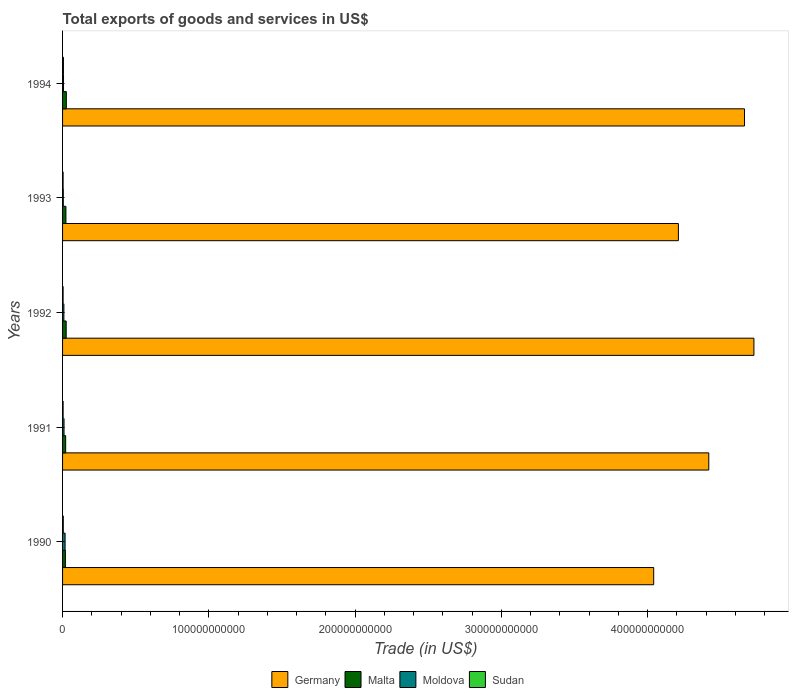How many groups of bars are there?
Give a very brief answer. 5. Are the number of bars on each tick of the Y-axis equal?
Your answer should be compact. Yes. How many bars are there on the 5th tick from the top?
Give a very brief answer. 4. How many bars are there on the 3rd tick from the bottom?
Offer a very short reply. 4. What is the total exports of goods and services in Malta in 1991?
Provide a succinct answer. 2.13e+09. Across all years, what is the maximum total exports of goods and services in Moldova?
Your response must be concise. 1.73e+09. Across all years, what is the minimum total exports of goods and services in Sudan?
Offer a very short reply. 3.69e+08. In which year was the total exports of goods and services in Sudan maximum?
Make the answer very short. 1994. In which year was the total exports of goods and services in Moldova minimum?
Ensure brevity in your answer.  1993. What is the total total exports of goods and services in Malta in the graph?
Your answer should be very brief. 1.14e+1. What is the difference between the total exports of goods and services in Sudan in 1992 and that in 1994?
Make the answer very short. -2.31e+08. What is the difference between the total exports of goods and services in Sudan in 1994 and the total exports of goods and services in Malta in 1993?
Your answer should be very brief. -1.70e+09. What is the average total exports of goods and services in Sudan per year?
Keep it short and to the point. 4.45e+08. In the year 1994, what is the difference between the total exports of goods and services in Sudan and total exports of goods and services in Malta?
Make the answer very short. -1.98e+09. What is the ratio of the total exports of goods and services in Sudan in 1992 to that in 1993?
Your answer should be compact. 0.98. Is the difference between the total exports of goods and services in Sudan in 1991 and 1994 greater than the difference between the total exports of goods and services in Malta in 1991 and 1994?
Your response must be concise. Yes. What is the difference between the highest and the second highest total exports of goods and services in Moldova?
Offer a terse response. 7.33e+08. What is the difference between the highest and the lowest total exports of goods and services in Moldova?
Your response must be concise. 1.23e+09. Is the sum of the total exports of goods and services in Moldova in 1991 and 1994 greater than the maximum total exports of goods and services in Malta across all years?
Your response must be concise. No. What does the 1st bar from the top in 1994 represents?
Offer a very short reply. Sudan. What does the 4th bar from the bottom in 1993 represents?
Keep it short and to the point. Sudan. How many bars are there?
Give a very brief answer. 20. What is the difference between two consecutive major ticks on the X-axis?
Provide a short and direct response. 1.00e+11. Are the values on the major ticks of X-axis written in scientific E-notation?
Offer a terse response. No. Does the graph contain grids?
Make the answer very short. No. How many legend labels are there?
Your answer should be very brief. 4. What is the title of the graph?
Keep it short and to the point. Total exports of goods and services in US$. Does "Hungary" appear as one of the legend labels in the graph?
Your answer should be very brief. No. What is the label or title of the X-axis?
Your answer should be compact. Trade (in US$). What is the Trade (in US$) in Germany in 1990?
Give a very brief answer. 4.04e+11. What is the Trade (in US$) in Malta in 1990?
Make the answer very short. 1.93e+09. What is the Trade (in US$) in Moldova in 1990?
Your answer should be very brief. 1.73e+09. What is the Trade (in US$) in Sudan in 1990?
Give a very brief answer. 4.99e+08. What is the Trade (in US$) in Germany in 1991?
Your answer should be very brief. 4.42e+11. What is the Trade (in US$) of Malta in 1991?
Keep it short and to the point. 2.13e+09. What is the Trade (in US$) in Moldova in 1991?
Give a very brief answer. 1.00e+09. What is the Trade (in US$) of Sudan in 1991?
Your response must be concise. 3.80e+08. What is the Trade (in US$) in Germany in 1992?
Keep it short and to the point. 4.73e+11. What is the Trade (in US$) in Malta in 1992?
Provide a succinct answer. 2.47e+09. What is the Trade (in US$) of Moldova in 1992?
Make the answer very short. 9.03e+08. What is the Trade (in US$) in Sudan in 1992?
Your answer should be compact. 3.69e+08. What is the Trade (in US$) in Germany in 1993?
Provide a succinct answer. 4.21e+11. What is the Trade (in US$) in Malta in 1993?
Your answer should be compact. 2.30e+09. What is the Trade (in US$) in Moldova in 1993?
Give a very brief answer. 5.01e+08. What is the Trade (in US$) in Sudan in 1993?
Provide a succinct answer. 3.76e+08. What is the Trade (in US$) of Germany in 1994?
Provide a short and direct response. 4.66e+11. What is the Trade (in US$) in Malta in 1994?
Your answer should be compact. 2.58e+09. What is the Trade (in US$) of Moldova in 1994?
Make the answer very short. 6.51e+08. What is the Trade (in US$) in Sudan in 1994?
Your response must be concise. 6.00e+08. Across all years, what is the maximum Trade (in US$) in Germany?
Ensure brevity in your answer.  4.73e+11. Across all years, what is the maximum Trade (in US$) in Malta?
Your answer should be very brief. 2.58e+09. Across all years, what is the maximum Trade (in US$) of Moldova?
Make the answer very short. 1.73e+09. Across all years, what is the maximum Trade (in US$) in Sudan?
Offer a terse response. 6.00e+08. Across all years, what is the minimum Trade (in US$) in Germany?
Keep it short and to the point. 4.04e+11. Across all years, what is the minimum Trade (in US$) in Malta?
Make the answer very short. 1.93e+09. Across all years, what is the minimum Trade (in US$) in Moldova?
Your answer should be compact. 5.01e+08. Across all years, what is the minimum Trade (in US$) in Sudan?
Keep it short and to the point. 3.69e+08. What is the total Trade (in US$) in Germany in the graph?
Keep it short and to the point. 2.21e+12. What is the total Trade (in US$) of Malta in the graph?
Keep it short and to the point. 1.14e+1. What is the total Trade (in US$) of Moldova in the graph?
Your response must be concise. 4.79e+09. What is the total Trade (in US$) of Sudan in the graph?
Keep it short and to the point. 2.22e+09. What is the difference between the Trade (in US$) of Germany in 1990 and that in 1991?
Your response must be concise. -3.77e+1. What is the difference between the Trade (in US$) in Malta in 1990 and that in 1991?
Provide a short and direct response. -1.96e+08. What is the difference between the Trade (in US$) in Moldova in 1990 and that in 1991?
Offer a terse response. 7.33e+08. What is the difference between the Trade (in US$) in Sudan in 1990 and that in 1991?
Your answer should be compact. 1.20e+08. What is the difference between the Trade (in US$) in Germany in 1990 and that in 1992?
Your response must be concise. -6.85e+1. What is the difference between the Trade (in US$) in Malta in 1990 and that in 1992?
Ensure brevity in your answer.  -5.39e+08. What is the difference between the Trade (in US$) of Moldova in 1990 and that in 1992?
Make the answer very short. 8.29e+08. What is the difference between the Trade (in US$) of Sudan in 1990 and that in 1992?
Make the answer very short. 1.30e+08. What is the difference between the Trade (in US$) of Germany in 1990 and that in 1993?
Provide a short and direct response. -1.69e+1. What is the difference between the Trade (in US$) of Malta in 1990 and that in 1993?
Offer a terse response. -3.66e+08. What is the difference between the Trade (in US$) of Moldova in 1990 and that in 1993?
Offer a terse response. 1.23e+09. What is the difference between the Trade (in US$) in Sudan in 1990 and that in 1993?
Your answer should be very brief. 1.23e+08. What is the difference between the Trade (in US$) of Germany in 1990 and that in 1994?
Your answer should be very brief. -6.21e+1. What is the difference between the Trade (in US$) of Malta in 1990 and that in 1994?
Your response must be concise. -6.46e+08. What is the difference between the Trade (in US$) in Moldova in 1990 and that in 1994?
Your response must be concise. 1.08e+09. What is the difference between the Trade (in US$) of Sudan in 1990 and that in 1994?
Provide a short and direct response. -1.01e+08. What is the difference between the Trade (in US$) in Germany in 1991 and that in 1992?
Give a very brief answer. -3.09e+1. What is the difference between the Trade (in US$) of Malta in 1991 and that in 1992?
Give a very brief answer. -3.43e+08. What is the difference between the Trade (in US$) in Moldova in 1991 and that in 1992?
Keep it short and to the point. 9.65e+07. What is the difference between the Trade (in US$) of Sudan in 1991 and that in 1992?
Give a very brief answer. 1.05e+07. What is the difference between the Trade (in US$) of Germany in 1991 and that in 1993?
Offer a very short reply. 2.08e+1. What is the difference between the Trade (in US$) in Malta in 1991 and that in 1993?
Your answer should be compact. -1.70e+08. What is the difference between the Trade (in US$) in Moldova in 1991 and that in 1993?
Your answer should be compact. 4.99e+08. What is the difference between the Trade (in US$) of Sudan in 1991 and that in 1993?
Offer a very short reply. 3.77e+06. What is the difference between the Trade (in US$) in Germany in 1991 and that in 1994?
Keep it short and to the point. -2.44e+1. What is the difference between the Trade (in US$) of Malta in 1991 and that in 1994?
Your answer should be very brief. -4.50e+08. What is the difference between the Trade (in US$) in Moldova in 1991 and that in 1994?
Offer a terse response. 3.49e+08. What is the difference between the Trade (in US$) of Sudan in 1991 and that in 1994?
Your answer should be very brief. -2.21e+08. What is the difference between the Trade (in US$) in Germany in 1992 and that in 1993?
Give a very brief answer. 5.16e+1. What is the difference between the Trade (in US$) in Malta in 1992 and that in 1993?
Your answer should be compact. 1.73e+08. What is the difference between the Trade (in US$) in Moldova in 1992 and that in 1993?
Ensure brevity in your answer.  4.02e+08. What is the difference between the Trade (in US$) of Sudan in 1992 and that in 1993?
Ensure brevity in your answer.  -6.71e+06. What is the difference between the Trade (in US$) of Germany in 1992 and that in 1994?
Your response must be concise. 6.46e+09. What is the difference between the Trade (in US$) in Malta in 1992 and that in 1994?
Your answer should be compact. -1.07e+08. What is the difference between the Trade (in US$) of Moldova in 1992 and that in 1994?
Your answer should be compact. 2.52e+08. What is the difference between the Trade (in US$) of Sudan in 1992 and that in 1994?
Offer a very short reply. -2.31e+08. What is the difference between the Trade (in US$) in Germany in 1993 and that in 1994?
Give a very brief answer. -4.52e+1. What is the difference between the Trade (in US$) of Malta in 1993 and that in 1994?
Provide a succinct answer. -2.80e+08. What is the difference between the Trade (in US$) of Moldova in 1993 and that in 1994?
Provide a short and direct response. -1.50e+08. What is the difference between the Trade (in US$) of Sudan in 1993 and that in 1994?
Offer a terse response. -2.24e+08. What is the difference between the Trade (in US$) of Germany in 1990 and the Trade (in US$) of Malta in 1991?
Your answer should be compact. 4.02e+11. What is the difference between the Trade (in US$) of Germany in 1990 and the Trade (in US$) of Moldova in 1991?
Ensure brevity in your answer.  4.03e+11. What is the difference between the Trade (in US$) of Germany in 1990 and the Trade (in US$) of Sudan in 1991?
Ensure brevity in your answer.  4.04e+11. What is the difference between the Trade (in US$) of Malta in 1990 and the Trade (in US$) of Moldova in 1991?
Your answer should be very brief. 9.32e+08. What is the difference between the Trade (in US$) in Malta in 1990 and the Trade (in US$) in Sudan in 1991?
Offer a terse response. 1.55e+09. What is the difference between the Trade (in US$) in Moldova in 1990 and the Trade (in US$) in Sudan in 1991?
Make the answer very short. 1.35e+09. What is the difference between the Trade (in US$) in Germany in 1990 and the Trade (in US$) in Malta in 1992?
Offer a very short reply. 4.02e+11. What is the difference between the Trade (in US$) of Germany in 1990 and the Trade (in US$) of Moldova in 1992?
Provide a short and direct response. 4.03e+11. What is the difference between the Trade (in US$) of Germany in 1990 and the Trade (in US$) of Sudan in 1992?
Ensure brevity in your answer.  4.04e+11. What is the difference between the Trade (in US$) of Malta in 1990 and the Trade (in US$) of Moldova in 1992?
Give a very brief answer. 1.03e+09. What is the difference between the Trade (in US$) of Malta in 1990 and the Trade (in US$) of Sudan in 1992?
Your answer should be very brief. 1.56e+09. What is the difference between the Trade (in US$) in Moldova in 1990 and the Trade (in US$) in Sudan in 1992?
Keep it short and to the point. 1.36e+09. What is the difference between the Trade (in US$) in Germany in 1990 and the Trade (in US$) in Malta in 1993?
Keep it short and to the point. 4.02e+11. What is the difference between the Trade (in US$) of Germany in 1990 and the Trade (in US$) of Moldova in 1993?
Offer a very short reply. 4.04e+11. What is the difference between the Trade (in US$) of Germany in 1990 and the Trade (in US$) of Sudan in 1993?
Give a very brief answer. 4.04e+11. What is the difference between the Trade (in US$) of Malta in 1990 and the Trade (in US$) of Moldova in 1993?
Your response must be concise. 1.43e+09. What is the difference between the Trade (in US$) in Malta in 1990 and the Trade (in US$) in Sudan in 1993?
Offer a terse response. 1.56e+09. What is the difference between the Trade (in US$) in Moldova in 1990 and the Trade (in US$) in Sudan in 1993?
Your answer should be compact. 1.36e+09. What is the difference between the Trade (in US$) in Germany in 1990 and the Trade (in US$) in Malta in 1994?
Give a very brief answer. 4.02e+11. What is the difference between the Trade (in US$) of Germany in 1990 and the Trade (in US$) of Moldova in 1994?
Make the answer very short. 4.04e+11. What is the difference between the Trade (in US$) in Germany in 1990 and the Trade (in US$) in Sudan in 1994?
Provide a succinct answer. 4.04e+11. What is the difference between the Trade (in US$) in Malta in 1990 and the Trade (in US$) in Moldova in 1994?
Keep it short and to the point. 1.28e+09. What is the difference between the Trade (in US$) of Malta in 1990 and the Trade (in US$) of Sudan in 1994?
Give a very brief answer. 1.33e+09. What is the difference between the Trade (in US$) in Moldova in 1990 and the Trade (in US$) in Sudan in 1994?
Give a very brief answer. 1.13e+09. What is the difference between the Trade (in US$) of Germany in 1991 and the Trade (in US$) of Malta in 1992?
Keep it short and to the point. 4.39e+11. What is the difference between the Trade (in US$) in Germany in 1991 and the Trade (in US$) in Moldova in 1992?
Keep it short and to the point. 4.41e+11. What is the difference between the Trade (in US$) in Germany in 1991 and the Trade (in US$) in Sudan in 1992?
Offer a terse response. 4.41e+11. What is the difference between the Trade (in US$) of Malta in 1991 and the Trade (in US$) of Moldova in 1992?
Your answer should be very brief. 1.22e+09. What is the difference between the Trade (in US$) of Malta in 1991 and the Trade (in US$) of Sudan in 1992?
Your response must be concise. 1.76e+09. What is the difference between the Trade (in US$) of Moldova in 1991 and the Trade (in US$) of Sudan in 1992?
Provide a succinct answer. 6.31e+08. What is the difference between the Trade (in US$) of Germany in 1991 and the Trade (in US$) of Malta in 1993?
Your answer should be very brief. 4.40e+11. What is the difference between the Trade (in US$) in Germany in 1991 and the Trade (in US$) in Moldova in 1993?
Your answer should be compact. 4.41e+11. What is the difference between the Trade (in US$) of Germany in 1991 and the Trade (in US$) of Sudan in 1993?
Offer a very short reply. 4.41e+11. What is the difference between the Trade (in US$) in Malta in 1991 and the Trade (in US$) in Moldova in 1993?
Give a very brief answer. 1.63e+09. What is the difference between the Trade (in US$) of Malta in 1991 and the Trade (in US$) of Sudan in 1993?
Keep it short and to the point. 1.75e+09. What is the difference between the Trade (in US$) in Moldova in 1991 and the Trade (in US$) in Sudan in 1993?
Your answer should be very brief. 6.24e+08. What is the difference between the Trade (in US$) in Germany in 1991 and the Trade (in US$) in Malta in 1994?
Offer a terse response. 4.39e+11. What is the difference between the Trade (in US$) of Germany in 1991 and the Trade (in US$) of Moldova in 1994?
Give a very brief answer. 4.41e+11. What is the difference between the Trade (in US$) in Germany in 1991 and the Trade (in US$) in Sudan in 1994?
Offer a terse response. 4.41e+11. What is the difference between the Trade (in US$) of Malta in 1991 and the Trade (in US$) of Moldova in 1994?
Your answer should be compact. 1.48e+09. What is the difference between the Trade (in US$) in Malta in 1991 and the Trade (in US$) in Sudan in 1994?
Provide a short and direct response. 1.53e+09. What is the difference between the Trade (in US$) in Moldova in 1991 and the Trade (in US$) in Sudan in 1994?
Ensure brevity in your answer.  4.00e+08. What is the difference between the Trade (in US$) in Germany in 1992 and the Trade (in US$) in Malta in 1993?
Your answer should be very brief. 4.70e+11. What is the difference between the Trade (in US$) of Germany in 1992 and the Trade (in US$) of Moldova in 1993?
Make the answer very short. 4.72e+11. What is the difference between the Trade (in US$) of Germany in 1992 and the Trade (in US$) of Sudan in 1993?
Offer a terse response. 4.72e+11. What is the difference between the Trade (in US$) in Malta in 1992 and the Trade (in US$) in Moldova in 1993?
Offer a terse response. 1.97e+09. What is the difference between the Trade (in US$) of Malta in 1992 and the Trade (in US$) of Sudan in 1993?
Offer a very short reply. 2.09e+09. What is the difference between the Trade (in US$) of Moldova in 1992 and the Trade (in US$) of Sudan in 1993?
Provide a succinct answer. 5.28e+08. What is the difference between the Trade (in US$) in Germany in 1992 and the Trade (in US$) in Malta in 1994?
Ensure brevity in your answer.  4.70e+11. What is the difference between the Trade (in US$) of Germany in 1992 and the Trade (in US$) of Moldova in 1994?
Offer a terse response. 4.72e+11. What is the difference between the Trade (in US$) in Germany in 1992 and the Trade (in US$) in Sudan in 1994?
Provide a short and direct response. 4.72e+11. What is the difference between the Trade (in US$) in Malta in 1992 and the Trade (in US$) in Moldova in 1994?
Offer a very short reply. 1.82e+09. What is the difference between the Trade (in US$) in Malta in 1992 and the Trade (in US$) in Sudan in 1994?
Offer a terse response. 1.87e+09. What is the difference between the Trade (in US$) in Moldova in 1992 and the Trade (in US$) in Sudan in 1994?
Offer a terse response. 3.03e+08. What is the difference between the Trade (in US$) of Germany in 1993 and the Trade (in US$) of Malta in 1994?
Offer a terse response. 4.18e+11. What is the difference between the Trade (in US$) of Germany in 1993 and the Trade (in US$) of Moldova in 1994?
Your answer should be compact. 4.20e+11. What is the difference between the Trade (in US$) of Germany in 1993 and the Trade (in US$) of Sudan in 1994?
Give a very brief answer. 4.20e+11. What is the difference between the Trade (in US$) of Malta in 1993 and the Trade (in US$) of Moldova in 1994?
Make the answer very short. 1.65e+09. What is the difference between the Trade (in US$) of Malta in 1993 and the Trade (in US$) of Sudan in 1994?
Provide a short and direct response. 1.70e+09. What is the difference between the Trade (in US$) in Moldova in 1993 and the Trade (in US$) in Sudan in 1994?
Provide a short and direct response. -9.91e+07. What is the average Trade (in US$) of Germany per year?
Offer a very short reply. 4.41e+11. What is the average Trade (in US$) of Malta per year?
Ensure brevity in your answer.  2.28e+09. What is the average Trade (in US$) in Moldova per year?
Offer a very short reply. 9.58e+08. What is the average Trade (in US$) of Sudan per year?
Your response must be concise. 4.45e+08. In the year 1990, what is the difference between the Trade (in US$) in Germany and Trade (in US$) in Malta?
Keep it short and to the point. 4.02e+11. In the year 1990, what is the difference between the Trade (in US$) in Germany and Trade (in US$) in Moldova?
Give a very brief answer. 4.02e+11. In the year 1990, what is the difference between the Trade (in US$) of Germany and Trade (in US$) of Sudan?
Your answer should be compact. 4.04e+11. In the year 1990, what is the difference between the Trade (in US$) in Malta and Trade (in US$) in Moldova?
Keep it short and to the point. 1.99e+08. In the year 1990, what is the difference between the Trade (in US$) of Malta and Trade (in US$) of Sudan?
Ensure brevity in your answer.  1.43e+09. In the year 1990, what is the difference between the Trade (in US$) in Moldova and Trade (in US$) in Sudan?
Offer a very short reply. 1.23e+09. In the year 1991, what is the difference between the Trade (in US$) of Germany and Trade (in US$) of Malta?
Offer a terse response. 4.40e+11. In the year 1991, what is the difference between the Trade (in US$) in Germany and Trade (in US$) in Moldova?
Provide a succinct answer. 4.41e+11. In the year 1991, what is the difference between the Trade (in US$) of Germany and Trade (in US$) of Sudan?
Offer a very short reply. 4.41e+11. In the year 1991, what is the difference between the Trade (in US$) in Malta and Trade (in US$) in Moldova?
Provide a succinct answer. 1.13e+09. In the year 1991, what is the difference between the Trade (in US$) of Malta and Trade (in US$) of Sudan?
Offer a very short reply. 1.75e+09. In the year 1991, what is the difference between the Trade (in US$) of Moldova and Trade (in US$) of Sudan?
Offer a terse response. 6.20e+08. In the year 1992, what is the difference between the Trade (in US$) in Germany and Trade (in US$) in Malta?
Your answer should be very brief. 4.70e+11. In the year 1992, what is the difference between the Trade (in US$) in Germany and Trade (in US$) in Moldova?
Provide a short and direct response. 4.72e+11. In the year 1992, what is the difference between the Trade (in US$) of Germany and Trade (in US$) of Sudan?
Offer a terse response. 4.72e+11. In the year 1992, what is the difference between the Trade (in US$) of Malta and Trade (in US$) of Moldova?
Provide a succinct answer. 1.57e+09. In the year 1992, what is the difference between the Trade (in US$) in Malta and Trade (in US$) in Sudan?
Provide a succinct answer. 2.10e+09. In the year 1992, what is the difference between the Trade (in US$) in Moldova and Trade (in US$) in Sudan?
Make the answer very short. 5.34e+08. In the year 1993, what is the difference between the Trade (in US$) of Germany and Trade (in US$) of Malta?
Your response must be concise. 4.19e+11. In the year 1993, what is the difference between the Trade (in US$) in Germany and Trade (in US$) in Moldova?
Provide a succinct answer. 4.21e+11. In the year 1993, what is the difference between the Trade (in US$) in Germany and Trade (in US$) in Sudan?
Ensure brevity in your answer.  4.21e+11. In the year 1993, what is the difference between the Trade (in US$) in Malta and Trade (in US$) in Moldova?
Offer a very short reply. 1.80e+09. In the year 1993, what is the difference between the Trade (in US$) of Malta and Trade (in US$) of Sudan?
Your answer should be compact. 1.92e+09. In the year 1993, what is the difference between the Trade (in US$) of Moldova and Trade (in US$) of Sudan?
Your response must be concise. 1.25e+08. In the year 1994, what is the difference between the Trade (in US$) of Germany and Trade (in US$) of Malta?
Ensure brevity in your answer.  4.64e+11. In the year 1994, what is the difference between the Trade (in US$) in Germany and Trade (in US$) in Moldova?
Your answer should be compact. 4.66e+11. In the year 1994, what is the difference between the Trade (in US$) of Germany and Trade (in US$) of Sudan?
Your answer should be compact. 4.66e+11. In the year 1994, what is the difference between the Trade (in US$) in Malta and Trade (in US$) in Moldova?
Ensure brevity in your answer.  1.93e+09. In the year 1994, what is the difference between the Trade (in US$) in Malta and Trade (in US$) in Sudan?
Offer a terse response. 1.98e+09. In the year 1994, what is the difference between the Trade (in US$) in Moldova and Trade (in US$) in Sudan?
Keep it short and to the point. 5.09e+07. What is the ratio of the Trade (in US$) of Germany in 1990 to that in 1991?
Provide a short and direct response. 0.91. What is the ratio of the Trade (in US$) in Malta in 1990 to that in 1991?
Keep it short and to the point. 0.91. What is the ratio of the Trade (in US$) of Moldova in 1990 to that in 1991?
Provide a succinct answer. 1.73. What is the ratio of the Trade (in US$) in Sudan in 1990 to that in 1991?
Make the answer very short. 1.31. What is the ratio of the Trade (in US$) of Germany in 1990 to that in 1992?
Make the answer very short. 0.85. What is the ratio of the Trade (in US$) in Malta in 1990 to that in 1992?
Ensure brevity in your answer.  0.78. What is the ratio of the Trade (in US$) in Moldova in 1990 to that in 1992?
Keep it short and to the point. 1.92. What is the ratio of the Trade (in US$) in Sudan in 1990 to that in 1992?
Ensure brevity in your answer.  1.35. What is the ratio of the Trade (in US$) of Germany in 1990 to that in 1993?
Provide a short and direct response. 0.96. What is the ratio of the Trade (in US$) of Malta in 1990 to that in 1993?
Make the answer very short. 0.84. What is the ratio of the Trade (in US$) in Moldova in 1990 to that in 1993?
Provide a short and direct response. 3.46. What is the ratio of the Trade (in US$) in Sudan in 1990 to that in 1993?
Provide a short and direct response. 1.33. What is the ratio of the Trade (in US$) of Germany in 1990 to that in 1994?
Provide a succinct answer. 0.87. What is the ratio of the Trade (in US$) in Malta in 1990 to that in 1994?
Your answer should be compact. 0.75. What is the ratio of the Trade (in US$) in Moldova in 1990 to that in 1994?
Give a very brief answer. 2.66. What is the ratio of the Trade (in US$) in Sudan in 1990 to that in 1994?
Offer a terse response. 0.83. What is the ratio of the Trade (in US$) in Germany in 1991 to that in 1992?
Offer a terse response. 0.93. What is the ratio of the Trade (in US$) in Malta in 1991 to that in 1992?
Your response must be concise. 0.86. What is the ratio of the Trade (in US$) of Moldova in 1991 to that in 1992?
Offer a terse response. 1.11. What is the ratio of the Trade (in US$) of Sudan in 1991 to that in 1992?
Offer a very short reply. 1.03. What is the ratio of the Trade (in US$) of Germany in 1991 to that in 1993?
Provide a short and direct response. 1.05. What is the ratio of the Trade (in US$) in Malta in 1991 to that in 1993?
Your response must be concise. 0.93. What is the ratio of the Trade (in US$) of Moldova in 1991 to that in 1993?
Your answer should be compact. 2. What is the ratio of the Trade (in US$) of Sudan in 1991 to that in 1993?
Provide a short and direct response. 1.01. What is the ratio of the Trade (in US$) in Germany in 1991 to that in 1994?
Your response must be concise. 0.95. What is the ratio of the Trade (in US$) in Malta in 1991 to that in 1994?
Your response must be concise. 0.83. What is the ratio of the Trade (in US$) in Moldova in 1991 to that in 1994?
Ensure brevity in your answer.  1.54. What is the ratio of the Trade (in US$) of Sudan in 1991 to that in 1994?
Your answer should be very brief. 0.63. What is the ratio of the Trade (in US$) of Germany in 1992 to that in 1993?
Offer a terse response. 1.12. What is the ratio of the Trade (in US$) of Malta in 1992 to that in 1993?
Provide a short and direct response. 1.08. What is the ratio of the Trade (in US$) of Moldova in 1992 to that in 1993?
Your answer should be compact. 1.8. What is the ratio of the Trade (in US$) in Sudan in 1992 to that in 1993?
Give a very brief answer. 0.98. What is the ratio of the Trade (in US$) of Germany in 1992 to that in 1994?
Provide a succinct answer. 1.01. What is the ratio of the Trade (in US$) of Malta in 1992 to that in 1994?
Offer a terse response. 0.96. What is the ratio of the Trade (in US$) in Moldova in 1992 to that in 1994?
Give a very brief answer. 1.39. What is the ratio of the Trade (in US$) of Sudan in 1992 to that in 1994?
Ensure brevity in your answer.  0.61. What is the ratio of the Trade (in US$) of Germany in 1993 to that in 1994?
Provide a succinct answer. 0.9. What is the ratio of the Trade (in US$) of Malta in 1993 to that in 1994?
Make the answer very short. 0.89. What is the ratio of the Trade (in US$) of Moldova in 1993 to that in 1994?
Your response must be concise. 0.77. What is the ratio of the Trade (in US$) of Sudan in 1993 to that in 1994?
Give a very brief answer. 0.63. What is the difference between the highest and the second highest Trade (in US$) in Germany?
Your response must be concise. 6.46e+09. What is the difference between the highest and the second highest Trade (in US$) of Malta?
Your response must be concise. 1.07e+08. What is the difference between the highest and the second highest Trade (in US$) of Moldova?
Ensure brevity in your answer.  7.33e+08. What is the difference between the highest and the second highest Trade (in US$) in Sudan?
Keep it short and to the point. 1.01e+08. What is the difference between the highest and the lowest Trade (in US$) of Germany?
Your response must be concise. 6.85e+1. What is the difference between the highest and the lowest Trade (in US$) of Malta?
Provide a short and direct response. 6.46e+08. What is the difference between the highest and the lowest Trade (in US$) in Moldova?
Your response must be concise. 1.23e+09. What is the difference between the highest and the lowest Trade (in US$) of Sudan?
Offer a terse response. 2.31e+08. 